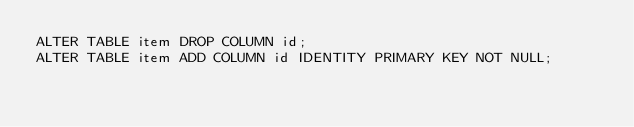Convert code to text. <code><loc_0><loc_0><loc_500><loc_500><_SQL_>ALTER TABLE item DROP COLUMN id;
ALTER TABLE item ADD COLUMN id IDENTITY PRIMARY KEY NOT NULL;
</code> 